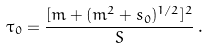Convert formula to latex. <formula><loc_0><loc_0><loc_500><loc_500>\tau _ { 0 } = \frac { [ m + ( m ^ { 2 } + s _ { 0 } ) ^ { 1 / 2 } ] ^ { 2 } } { S } \, .</formula> 